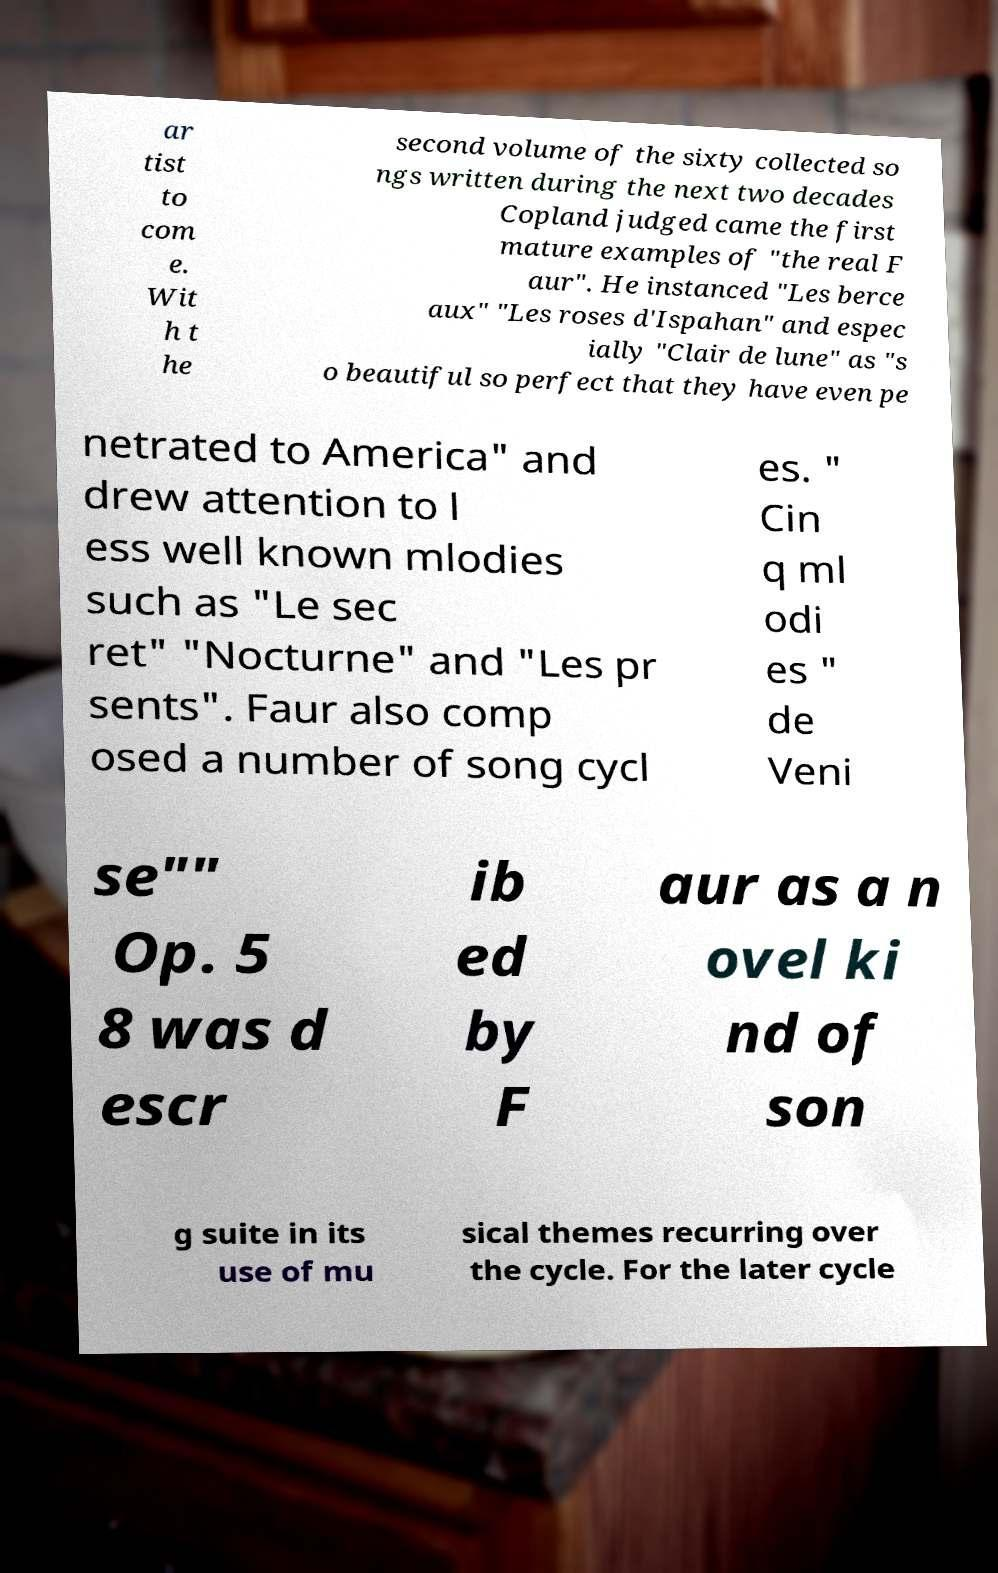For documentation purposes, I need the text within this image transcribed. Could you provide that? ar tist to com e. Wit h t he second volume of the sixty collected so ngs written during the next two decades Copland judged came the first mature examples of "the real F aur". He instanced "Les berce aux" "Les roses d'Ispahan" and espec ially "Clair de lune" as "s o beautiful so perfect that they have even pe netrated to America" and drew attention to l ess well known mlodies such as "Le sec ret" "Nocturne" and "Les pr sents". Faur also comp osed a number of song cycl es. " Cin q ml odi es " de Veni se"" Op. 5 8 was d escr ib ed by F aur as a n ovel ki nd of son g suite in its use of mu sical themes recurring over the cycle. For the later cycle 